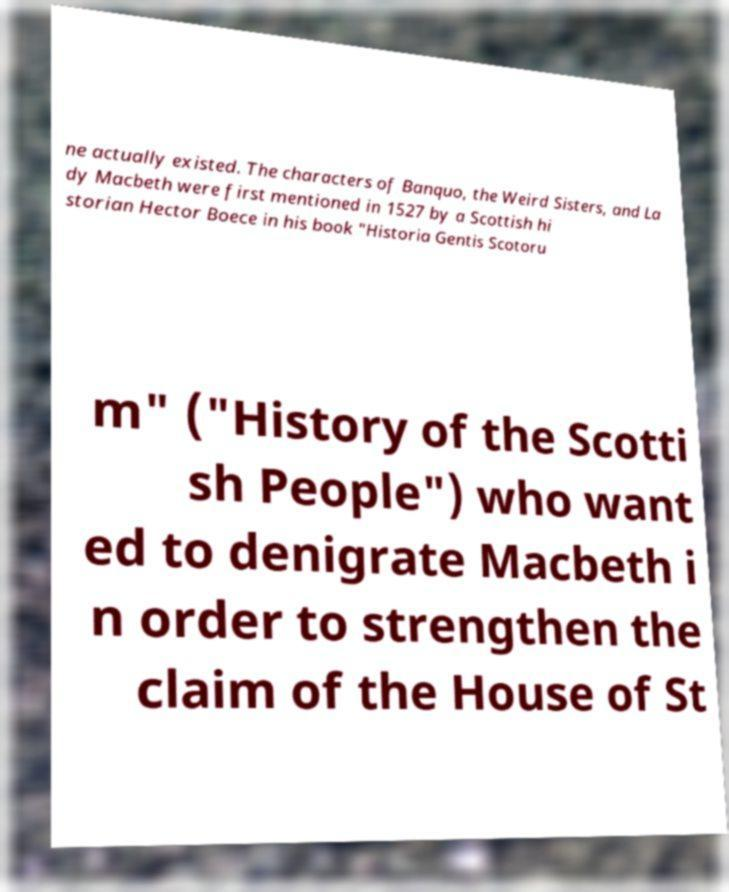Can you accurately transcribe the text from the provided image for me? ne actually existed. The characters of Banquo, the Weird Sisters, and La dy Macbeth were first mentioned in 1527 by a Scottish hi storian Hector Boece in his book "Historia Gentis Scotoru m" ("History of the Scotti sh People") who want ed to denigrate Macbeth i n order to strengthen the claim of the House of St 